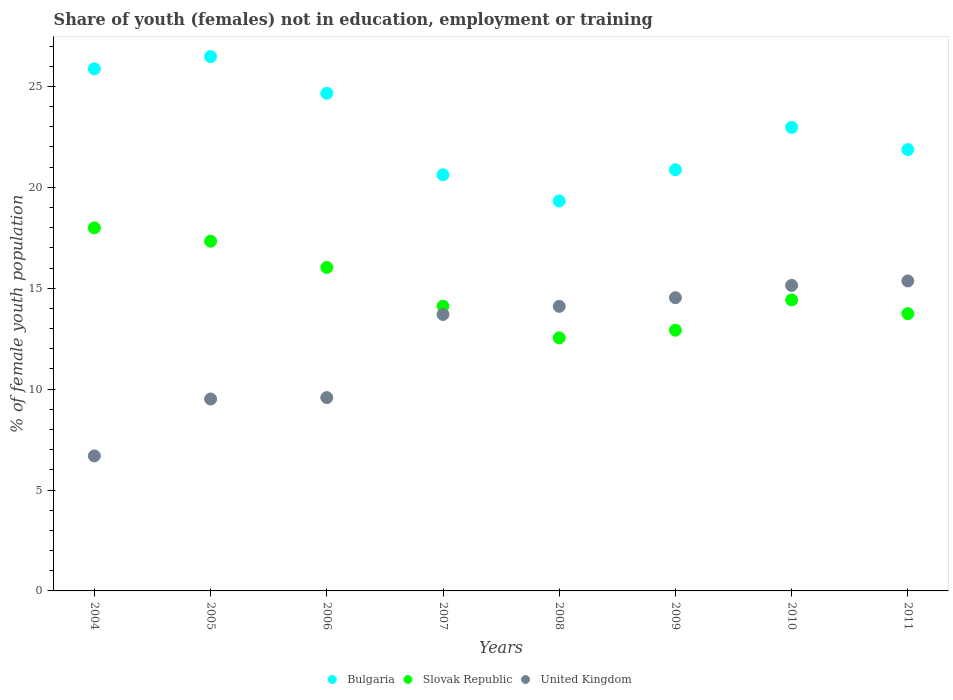How many different coloured dotlines are there?
Provide a short and direct response. 3. Is the number of dotlines equal to the number of legend labels?
Your answer should be compact. Yes. What is the percentage of unemployed female population in in Bulgaria in 2005?
Your answer should be compact. 26.48. Across all years, what is the maximum percentage of unemployed female population in in United Kingdom?
Provide a succinct answer. 15.36. Across all years, what is the minimum percentage of unemployed female population in in Bulgaria?
Your answer should be very brief. 19.32. In which year was the percentage of unemployed female population in in Slovak Republic maximum?
Your response must be concise. 2004. In which year was the percentage of unemployed female population in in Slovak Republic minimum?
Make the answer very short. 2008. What is the total percentage of unemployed female population in in United Kingdom in the graph?
Your answer should be compact. 98.61. What is the difference between the percentage of unemployed female population in in Bulgaria in 2004 and that in 2007?
Your response must be concise. 5.25. What is the difference between the percentage of unemployed female population in in Slovak Republic in 2006 and the percentage of unemployed female population in in United Kingdom in 2011?
Provide a succinct answer. 0.67. What is the average percentage of unemployed female population in in United Kingdom per year?
Provide a short and direct response. 12.33. In the year 2006, what is the difference between the percentage of unemployed female population in in Slovak Republic and percentage of unemployed female population in in Bulgaria?
Ensure brevity in your answer.  -8.63. What is the ratio of the percentage of unemployed female population in in Slovak Republic in 2004 to that in 2005?
Your answer should be compact. 1.04. Is the percentage of unemployed female population in in Slovak Republic in 2004 less than that in 2005?
Your answer should be very brief. No. Is the difference between the percentage of unemployed female population in in Slovak Republic in 2006 and 2007 greater than the difference between the percentage of unemployed female population in in Bulgaria in 2006 and 2007?
Make the answer very short. No. What is the difference between the highest and the second highest percentage of unemployed female population in in Slovak Republic?
Your answer should be very brief. 0.66. What is the difference between the highest and the lowest percentage of unemployed female population in in United Kingdom?
Give a very brief answer. 8.67. Is the sum of the percentage of unemployed female population in in Slovak Republic in 2007 and 2011 greater than the maximum percentage of unemployed female population in in Bulgaria across all years?
Your answer should be very brief. Yes. Does the graph contain any zero values?
Offer a very short reply. No. Does the graph contain grids?
Your answer should be compact. No. What is the title of the graph?
Keep it short and to the point. Share of youth (females) not in education, employment or training. What is the label or title of the Y-axis?
Keep it short and to the point. % of female youth population. What is the % of female youth population of Bulgaria in 2004?
Provide a short and direct response. 25.87. What is the % of female youth population in Slovak Republic in 2004?
Keep it short and to the point. 17.99. What is the % of female youth population of United Kingdom in 2004?
Provide a short and direct response. 6.69. What is the % of female youth population in Bulgaria in 2005?
Your answer should be compact. 26.48. What is the % of female youth population of Slovak Republic in 2005?
Offer a very short reply. 17.33. What is the % of female youth population in United Kingdom in 2005?
Provide a short and direct response. 9.51. What is the % of female youth population in Bulgaria in 2006?
Offer a terse response. 24.66. What is the % of female youth population of Slovak Republic in 2006?
Your answer should be very brief. 16.03. What is the % of female youth population of United Kingdom in 2006?
Keep it short and to the point. 9.58. What is the % of female youth population in Bulgaria in 2007?
Make the answer very short. 20.62. What is the % of female youth population in Slovak Republic in 2007?
Provide a succinct answer. 14.11. What is the % of female youth population in United Kingdom in 2007?
Ensure brevity in your answer.  13.7. What is the % of female youth population in Bulgaria in 2008?
Make the answer very short. 19.32. What is the % of female youth population of Slovak Republic in 2008?
Offer a very short reply. 12.54. What is the % of female youth population in United Kingdom in 2008?
Make the answer very short. 14.1. What is the % of female youth population in Bulgaria in 2009?
Keep it short and to the point. 20.87. What is the % of female youth population of Slovak Republic in 2009?
Keep it short and to the point. 12.92. What is the % of female youth population in United Kingdom in 2009?
Offer a very short reply. 14.53. What is the % of female youth population in Bulgaria in 2010?
Offer a terse response. 22.97. What is the % of female youth population in Slovak Republic in 2010?
Give a very brief answer. 14.42. What is the % of female youth population in United Kingdom in 2010?
Your answer should be very brief. 15.14. What is the % of female youth population of Bulgaria in 2011?
Keep it short and to the point. 21.87. What is the % of female youth population in Slovak Republic in 2011?
Give a very brief answer. 13.74. What is the % of female youth population in United Kingdom in 2011?
Make the answer very short. 15.36. Across all years, what is the maximum % of female youth population of Bulgaria?
Your response must be concise. 26.48. Across all years, what is the maximum % of female youth population in Slovak Republic?
Offer a very short reply. 17.99. Across all years, what is the maximum % of female youth population in United Kingdom?
Keep it short and to the point. 15.36. Across all years, what is the minimum % of female youth population of Bulgaria?
Make the answer very short. 19.32. Across all years, what is the minimum % of female youth population of Slovak Republic?
Keep it short and to the point. 12.54. Across all years, what is the minimum % of female youth population of United Kingdom?
Your response must be concise. 6.69. What is the total % of female youth population in Bulgaria in the graph?
Offer a terse response. 182.66. What is the total % of female youth population in Slovak Republic in the graph?
Your answer should be very brief. 119.08. What is the total % of female youth population in United Kingdom in the graph?
Your answer should be very brief. 98.61. What is the difference between the % of female youth population in Bulgaria in 2004 and that in 2005?
Your answer should be very brief. -0.61. What is the difference between the % of female youth population in Slovak Republic in 2004 and that in 2005?
Keep it short and to the point. 0.66. What is the difference between the % of female youth population of United Kingdom in 2004 and that in 2005?
Offer a terse response. -2.82. What is the difference between the % of female youth population in Bulgaria in 2004 and that in 2006?
Make the answer very short. 1.21. What is the difference between the % of female youth population in Slovak Republic in 2004 and that in 2006?
Keep it short and to the point. 1.96. What is the difference between the % of female youth population of United Kingdom in 2004 and that in 2006?
Your response must be concise. -2.89. What is the difference between the % of female youth population of Bulgaria in 2004 and that in 2007?
Provide a short and direct response. 5.25. What is the difference between the % of female youth population of Slovak Republic in 2004 and that in 2007?
Ensure brevity in your answer.  3.88. What is the difference between the % of female youth population in United Kingdom in 2004 and that in 2007?
Offer a terse response. -7.01. What is the difference between the % of female youth population of Bulgaria in 2004 and that in 2008?
Your response must be concise. 6.55. What is the difference between the % of female youth population of Slovak Republic in 2004 and that in 2008?
Your answer should be compact. 5.45. What is the difference between the % of female youth population in United Kingdom in 2004 and that in 2008?
Your answer should be compact. -7.41. What is the difference between the % of female youth population in Slovak Republic in 2004 and that in 2009?
Your answer should be compact. 5.07. What is the difference between the % of female youth population of United Kingdom in 2004 and that in 2009?
Your answer should be compact. -7.84. What is the difference between the % of female youth population in Slovak Republic in 2004 and that in 2010?
Keep it short and to the point. 3.57. What is the difference between the % of female youth population of United Kingdom in 2004 and that in 2010?
Provide a succinct answer. -8.45. What is the difference between the % of female youth population in Slovak Republic in 2004 and that in 2011?
Give a very brief answer. 4.25. What is the difference between the % of female youth population in United Kingdom in 2004 and that in 2011?
Ensure brevity in your answer.  -8.67. What is the difference between the % of female youth population of Bulgaria in 2005 and that in 2006?
Keep it short and to the point. 1.82. What is the difference between the % of female youth population of United Kingdom in 2005 and that in 2006?
Your answer should be compact. -0.07. What is the difference between the % of female youth population in Bulgaria in 2005 and that in 2007?
Make the answer very short. 5.86. What is the difference between the % of female youth population in Slovak Republic in 2005 and that in 2007?
Your answer should be very brief. 3.22. What is the difference between the % of female youth population of United Kingdom in 2005 and that in 2007?
Your answer should be very brief. -4.19. What is the difference between the % of female youth population in Bulgaria in 2005 and that in 2008?
Keep it short and to the point. 7.16. What is the difference between the % of female youth population of Slovak Republic in 2005 and that in 2008?
Offer a terse response. 4.79. What is the difference between the % of female youth population in United Kingdom in 2005 and that in 2008?
Keep it short and to the point. -4.59. What is the difference between the % of female youth population of Bulgaria in 2005 and that in 2009?
Your answer should be compact. 5.61. What is the difference between the % of female youth population of Slovak Republic in 2005 and that in 2009?
Your answer should be compact. 4.41. What is the difference between the % of female youth population of United Kingdom in 2005 and that in 2009?
Ensure brevity in your answer.  -5.02. What is the difference between the % of female youth population of Bulgaria in 2005 and that in 2010?
Provide a short and direct response. 3.51. What is the difference between the % of female youth population in Slovak Republic in 2005 and that in 2010?
Provide a succinct answer. 2.91. What is the difference between the % of female youth population in United Kingdom in 2005 and that in 2010?
Offer a terse response. -5.63. What is the difference between the % of female youth population of Bulgaria in 2005 and that in 2011?
Your answer should be compact. 4.61. What is the difference between the % of female youth population in Slovak Republic in 2005 and that in 2011?
Make the answer very short. 3.59. What is the difference between the % of female youth population in United Kingdom in 2005 and that in 2011?
Ensure brevity in your answer.  -5.85. What is the difference between the % of female youth population of Bulgaria in 2006 and that in 2007?
Offer a very short reply. 4.04. What is the difference between the % of female youth population in Slovak Republic in 2006 and that in 2007?
Offer a very short reply. 1.92. What is the difference between the % of female youth population in United Kingdom in 2006 and that in 2007?
Your answer should be very brief. -4.12. What is the difference between the % of female youth population in Bulgaria in 2006 and that in 2008?
Offer a very short reply. 5.34. What is the difference between the % of female youth population of Slovak Republic in 2006 and that in 2008?
Keep it short and to the point. 3.49. What is the difference between the % of female youth population of United Kingdom in 2006 and that in 2008?
Make the answer very short. -4.52. What is the difference between the % of female youth population in Bulgaria in 2006 and that in 2009?
Your response must be concise. 3.79. What is the difference between the % of female youth population of Slovak Republic in 2006 and that in 2009?
Your answer should be very brief. 3.11. What is the difference between the % of female youth population in United Kingdom in 2006 and that in 2009?
Offer a very short reply. -4.95. What is the difference between the % of female youth population in Bulgaria in 2006 and that in 2010?
Make the answer very short. 1.69. What is the difference between the % of female youth population in Slovak Republic in 2006 and that in 2010?
Your answer should be compact. 1.61. What is the difference between the % of female youth population in United Kingdom in 2006 and that in 2010?
Ensure brevity in your answer.  -5.56. What is the difference between the % of female youth population in Bulgaria in 2006 and that in 2011?
Offer a terse response. 2.79. What is the difference between the % of female youth population of Slovak Republic in 2006 and that in 2011?
Your answer should be very brief. 2.29. What is the difference between the % of female youth population of United Kingdom in 2006 and that in 2011?
Ensure brevity in your answer.  -5.78. What is the difference between the % of female youth population of Bulgaria in 2007 and that in 2008?
Your response must be concise. 1.3. What is the difference between the % of female youth population in Slovak Republic in 2007 and that in 2008?
Offer a very short reply. 1.57. What is the difference between the % of female youth population in United Kingdom in 2007 and that in 2008?
Offer a terse response. -0.4. What is the difference between the % of female youth population of Slovak Republic in 2007 and that in 2009?
Make the answer very short. 1.19. What is the difference between the % of female youth population of United Kingdom in 2007 and that in 2009?
Your response must be concise. -0.83. What is the difference between the % of female youth population of Bulgaria in 2007 and that in 2010?
Your answer should be very brief. -2.35. What is the difference between the % of female youth population of Slovak Republic in 2007 and that in 2010?
Make the answer very short. -0.31. What is the difference between the % of female youth population of United Kingdom in 2007 and that in 2010?
Offer a very short reply. -1.44. What is the difference between the % of female youth population of Bulgaria in 2007 and that in 2011?
Your response must be concise. -1.25. What is the difference between the % of female youth population of Slovak Republic in 2007 and that in 2011?
Provide a short and direct response. 0.37. What is the difference between the % of female youth population in United Kingdom in 2007 and that in 2011?
Provide a short and direct response. -1.66. What is the difference between the % of female youth population of Bulgaria in 2008 and that in 2009?
Provide a succinct answer. -1.55. What is the difference between the % of female youth population in Slovak Republic in 2008 and that in 2009?
Your answer should be compact. -0.38. What is the difference between the % of female youth population of United Kingdom in 2008 and that in 2009?
Offer a very short reply. -0.43. What is the difference between the % of female youth population in Bulgaria in 2008 and that in 2010?
Keep it short and to the point. -3.65. What is the difference between the % of female youth population of Slovak Republic in 2008 and that in 2010?
Provide a succinct answer. -1.88. What is the difference between the % of female youth population in United Kingdom in 2008 and that in 2010?
Ensure brevity in your answer.  -1.04. What is the difference between the % of female youth population in Bulgaria in 2008 and that in 2011?
Your answer should be very brief. -2.55. What is the difference between the % of female youth population in Slovak Republic in 2008 and that in 2011?
Give a very brief answer. -1.2. What is the difference between the % of female youth population of United Kingdom in 2008 and that in 2011?
Give a very brief answer. -1.26. What is the difference between the % of female youth population in Bulgaria in 2009 and that in 2010?
Provide a short and direct response. -2.1. What is the difference between the % of female youth population in Slovak Republic in 2009 and that in 2010?
Your answer should be very brief. -1.5. What is the difference between the % of female youth population in United Kingdom in 2009 and that in 2010?
Your answer should be very brief. -0.61. What is the difference between the % of female youth population of Slovak Republic in 2009 and that in 2011?
Your answer should be very brief. -0.82. What is the difference between the % of female youth population of United Kingdom in 2009 and that in 2011?
Provide a succinct answer. -0.83. What is the difference between the % of female youth population in Slovak Republic in 2010 and that in 2011?
Offer a terse response. 0.68. What is the difference between the % of female youth population in United Kingdom in 2010 and that in 2011?
Offer a terse response. -0.22. What is the difference between the % of female youth population of Bulgaria in 2004 and the % of female youth population of Slovak Republic in 2005?
Give a very brief answer. 8.54. What is the difference between the % of female youth population in Bulgaria in 2004 and the % of female youth population in United Kingdom in 2005?
Offer a terse response. 16.36. What is the difference between the % of female youth population of Slovak Republic in 2004 and the % of female youth population of United Kingdom in 2005?
Your answer should be compact. 8.48. What is the difference between the % of female youth population of Bulgaria in 2004 and the % of female youth population of Slovak Republic in 2006?
Your response must be concise. 9.84. What is the difference between the % of female youth population of Bulgaria in 2004 and the % of female youth population of United Kingdom in 2006?
Provide a short and direct response. 16.29. What is the difference between the % of female youth population in Slovak Republic in 2004 and the % of female youth population in United Kingdom in 2006?
Offer a very short reply. 8.41. What is the difference between the % of female youth population in Bulgaria in 2004 and the % of female youth population in Slovak Republic in 2007?
Provide a short and direct response. 11.76. What is the difference between the % of female youth population of Bulgaria in 2004 and the % of female youth population of United Kingdom in 2007?
Keep it short and to the point. 12.17. What is the difference between the % of female youth population in Slovak Republic in 2004 and the % of female youth population in United Kingdom in 2007?
Offer a very short reply. 4.29. What is the difference between the % of female youth population in Bulgaria in 2004 and the % of female youth population in Slovak Republic in 2008?
Your answer should be very brief. 13.33. What is the difference between the % of female youth population in Bulgaria in 2004 and the % of female youth population in United Kingdom in 2008?
Keep it short and to the point. 11.77. What is the difference between the % of female youth population of Slovak Republic in 2004 and the % of female youth population of United Kingdom in 2008?
Offer a terse response. 3.89. What is the difference between the % of female youth population of Bulgaria in 2004 and the % of female youth population of Slovak Republic in 2009?
Your answer should be compact. 12.95. What is the difference between the % of female youth population in Bulgaria in 2004 and the % of female youth population in United Kingdom in 2009?
Ensure brevity in your answer.  11.34. What is the difference between the % of female youth population of Slovak Republic in 2004 and the % of female youth population of United Kingdom in 2009?
Provide a succinct answer. 3.46. What is the difference between the % of female youth population of Bulgaria in 2004 and the % of female youth population of Slovak Republic in 2010?
Offer a terse response. 11.45. What is the difference between the % of female youth population of Bulgaria in 2004 and the % of female youth population of United Kingdom in 2010?
Offer a terse response. 10.73. What is the difference between the % of female youth population of Slovak Republic in 2004 and the % of female youth population of United Kingdom in 2010?
Offer a terse response. 2.85. What is the difference between the % of female youth population of Bulgaria in 2004 and the % of female youth population of Slovak Republic in 2011?
Ensure brevity in your answer.  12.13. What is the difference between the % of female youth population in Bulgaria in 2004 and the % of female youth population in United Kingdom in 2011?
Offer a very short reply. 10.51. What is the difference between the % of female youth population in Slovak Republic in 2004 and the % of female youth population in United Kingdom in 2011?
Offer a very short reply. 2.63. What is the difference between the % of female youth population of Bulgaria in 2005 and the % of female youth population of Slovak Republic in 2006?
Your answer should be very brief. 10.45. What is the difference between the % of female youth population of Bulgaria in 2005 and the % of female youth population of United Kingdom in 2006?
Your answer should be very brief. 16.9. What is the difference between the % of female youth population in Slovak Republic in 2005 and the % of female youth population in United Kingdom in 2006?
Offer a terse response. 7.75. What is the difference between the % of female youth population of Bulgaria in 2005 and the % of female youth population of Slovak Republic in 2007?
Make the answer very short. 12.37. What is the difference between the % of female youth population of Bulgaria in 2005 and the % of female youth population of United Kingdom in 2007?
Offer a terse response. 12.78. What is the difference between the % of female youth population of Slovak Republic in 2005 and the % of female youth population of United Kingdom in 2007?
Offer a very short reply. 3.63. What is the difference between the % of female youth population of Bulgaria in 2005 and the % of female youth population of Slovak Republic in 2008?
Keep it short and to the point. 13.94. What is the difference between the % of female youth population in Bulgaria in 2005 and the % of female youth population in United Kingdom in 2008?
Give a very brief answer. 12.38. What is the difference between the % of female youth population of Slovak Republic in 2005 and the % of female youth population of United Kingdom in 2008?
Provide a succinct answer. 3.23. What is the difference between the % of female youth population of Bulgaria in 2005 and the % of female youth population of Slovak Republic in 2009?
Offer a terse response. 13.56. What is the difference between the % of female youth population of Bulgaria in 2005 and the % of female youth population of United Kingdom in 2009?
Your answer should be very brief. 11.95. What is the difference between the % of female youth population of Slovak Republic in 2005 and the % of female youth population of United Kingdom in 2009?
Ensure brevity in your answer.  2.8. What is the difference between the % of female youth population in Bulgaria in 2005 and the % of female youth population in Slovak Republic in 2010?
Your answer should be very brief. 12.06. What is the difference between the % of female youth population in Bulgaria in 2005 and the % of female youth population in United Kingdom in 2010?
Your response must be concise. 11.34. What is the difference between the % of female youth population in Slovak Republic in 2005 and the % of female youth population in United Kingdom in 2010?
Offer a terse response. 2.19. What is the difference between the % of female youth population in Bulgaria in 2005 and the % of female youth population in Slovak Republic in 2011?
Offer a terse response. 12.74. What is the difference between the % of female youth population in Bulgaria in 2005 and the % of female youth population in United Kingdom in 2011?
Provide a succinct answer. 11.12. What is the difference between the % of female youth population in Slovak Republic in 2005 and the % of female youth population in United Kingdom in 2011?
Your response must be concise. 1.97. What is the difference between the % of female youth population in Bulgaria in 2006 and the % of female youth population in Slovak Republic in 2007?
Your answer should be compact. 10.55. What is the difference between the % of female youth population in Bulgaria in 2006 and the % of female youth population in United Kingdom in 2007?
Your answer should be compact. 10.96. What is the difference between the % of female youth population in Slovak Republic in 2006 and the % of female youth population in United Kingdom in 2007?
Your answer should be compact. 2.33. What is the difference between the % of female youth population of Bulgaria in 2006 and the % of female youth population of Slovak Republic in 2008?
Ensure brevity in your answer.  12.12. What is the difference between the % of female youth population in Bulgaria in 2006 and the % of female youth population in United Kingdom in 2008?
Your response must be concise. 10.56. What is the difference between the % of female youth population in Slovak Republic in 2006 and the % of female youth population in United Kingdom in 2008?
Offer a terse response. 1.93. What is the difference between the % of female youth population in Bulgaria in 2006 and the % of female youth population in Slovak Republic in 2009?
Offer a very short reply. 11.74. What is the difference between the % of female youth population in Bulgaria in 2006 and the % of female youth population in United Kingdom in 2009?
Make the answer very short. 10.13. What is the difference between the % of female youth population of Slovak Republic in 2006 and the % of female youth population of United Kingdom in 2009?
Your response must be concise. 1.5. What is the difference between the % of female youth population in Bulgaria in 2006 and the % of female youth population in Slovak Republic in 2010?
Provide a succinct answer. 10.24. What is the difference between the % of female youth population in Bulgaria in 2006 and the % of female youth population in United Kingdom in 2010?
Your answer should be compact. 9.52. What is the difference between the % of female youth population in Slovak Republic in 2006 and the % of female youth population in United Kingdom in 2010?
Ensure brevity in your answer.  0.89. What is the difference between the % of female youth population of Bulgaria in 2006 and the % of female youth population of Slovak Republic in 2011?
Keep it short and to the point. 10.92. What is the difference between the % of female youth population of Bulgaria in 2006 and the % of female youth population of United Kingdom in 2011?
Your answer should be compact. 9.3. What is the difference between the % of female youth population in Slovak Republic in 2006 and the % of female youth population in United Kingdom in 2011?
Offer a very short reply. 0.67. What is the difference between the % of female youth population in Bulgaria in 2007 and the % of female youth population in Slovak Republic in 2008?
Make the answer very short. 8.08. What is the difference between the % of female youth population in Bulgaria in 2007 and the % of female youth population in United Kingdom in 2008?
Give a very brief answer. 6.52. What is the difference between the % of female youth population in Slovak Republic in 2007 and the % of female youth population in United Kingdom in 2008?
Your answer should be compact. 0.01. What is the difference between the % of female youth population in Bulgaria in 2007 and the % of female youth population in United Kingdom in 2009?
Offer a very short reply. 6.09. What is the difference between the % of female youth population of Slovak Republic in 2007 and the % of female youth population of United Kingdom in 2009?
Provide a short and direct response. -0.42. What is the difference between the % of female youth population of Bulgaria in 2007 and the % of female youth population of United Kingdom in 2010?
Keep it short and to the point. 5.48. What is the difference between the % of female youth population in Slovak Republic in 2007 and the % of female youth population in United Kingdom in 2010?
Your answer should be compact. -1.03. What is the difference between the % of female youth population in Bulgaria in 2007 and the % of female youth population in Slovak Republic in 2011?
Offer a terse response. 6.88. What is the difference between the % of female youth population of Bulgaria in 2007 and the % of female youth population of United Kingdom in 2011?
Keep it short and to the point. 5.26. What is the difference between the % of female youth population in Slovak Republic in 2007 and the % of female youth population in United Kingdom in 2011?
Ensure brevity in your answer.  -1.25. What is the difference between the % of female youth population of Bulgaria in 2008 and the % of female youth population of Slovak Republic in 2009?
Give a very brief answer. 6.4. What is the difference between the % of female youth population in Bulgaria in 2008 and the % of female youth population in United Kingdom in 2009?
Your answer should be compact. 4.79. What is the difference between the % of female youth population of Slovak Republic in 2008 and the % of female youth population of United Kingdom in 2009?
Keep it short and to the point. -1.99. What is the difference between the % of female youth population of Bulgaria in 2008 and the % of female youth population of Slovak Republic in 2010?
Your answer should be very brief. 4.9. What is the difference between the % of female youth population in Bulgaria in 2008 and the % of female youth population in United Kingdom in 2010?
Offer a terse response. 4.18. What is the difference between the % of female youth population in Slovak Republic in 2008 and the % of female youth population in United Kingdom in 2010?
Your response must be concise. -2.6. What is the difference between the % of female youth population of Bulgaria in 2008 and the % of female youth population of Slovak Republic in 2011?
Keep it short and to the point. 5.58. What is the difference between the % of female youth population in Bulgaria in 2008 and the % of female youth population in United Kingdom in 2011?
Give a very brief answer. 3.96. What is the difference between the % of female youth population in Slovak Republic in 2008 and the % of female youth population in United Kingdom in 2011?
Make the answer very short. -2.82. What is the difference between the % of female youth population of Bulgaria in 2009 and the % of female youth population of Slovak Republic in 2010?
Provide a short and direct response. 6.45. What is the difference between the % of female youth population in Bulgaria in 2009 and the % of female youth population in United Kingdom in 2010?
Keep it short and to the point. 5.73. What is the difference between the % of female youth population in Slovak Republic in 2009 and the % of female youth population in United Kingdom in 2010?
Provide a succinct answer. -2.22. What is the difference between the % of female youth population in Bulgaria in 2009 and the % of female youth population in Slovak Republic in 2011?
Offer a very short reply. 7.13. What is the difference between the % of female youth population in Bulgaria in 2009 and the % of female youth population in United Kingdom in 2011?
Give a very brief answer. 5.51. What is the difference between the % of female youth population of Slovak Republic in 2009 and the % of female youth population of United Kingdom in 2011?
Give a very brief answer. -2.44. What is the difference between the % of female youth population of Bulgaria in 2010 and the % of female youth population of Slovak Republic in 2011?
Make the answer very short. 9.23. What is the difference between the % of female youth population in Bulgaria in 2010 and the % of female youth population in United Kingdom in 2011?
Keep it short and to the point. 7.61. What is the difference between the % of female youth population in Slovak Republic in 2010 and the % of female youth population in United Kingdom in 2011?
Your answer should be very brief. -0.94. What is the average % of female youth population of Bulgaria per year?
Your answer should be very brief. 22.83. What is the average % of female youth population in Slovak Republic per year?
Offer a very short reply. 14.88. What is the average % of female youth population in United Kingdom per year?
Your answer should be compact. 12.33. In the year 2004, what is the difference between the % of female youth population of Bulgaria and % of female youth population of Slovak Republic?
Provide a succinct answer. 7.88. In the year 2004, what is the difference between the % of female youth population in Bulgaria and % of female youth population in United Kingdom?
Your answer should be very brief. 19.18. In the year 2004, what is the difference between the % of female youth population of Slovak Republic and % of female youth population of United Kingdom?
Offer a terse response. 11.3. In the year 2005, what is the difference between the % of female youth population in Bulgaria and % of female youth population in Slovak Republic?
Your answer should be very brief. 9.15. In the year 2005, what is the difference between the % of female youth population of Bulgaria and % of female youth population of United Kingdom?
Your response must be concise. 16.97. In the year 2005, what is the difference between the % of female youth population of Slovak Republic and % of female youth population of United Kingdom?
Keep it short and to the point. 7.82. In the year 2006, what is the difference between the % of female youth population in Bulgaria and % of female youth population in Slovak Republic?
Your answer should be compact. 8.63. In the year 2006, what is the difference between the % of female youth population of Bulgaria and % of female youth population of United Kingdom?
Make the answer very short. 15.08. In the year 2006, what is the difference between the % of female youth population of Slovak Republic and % of female youth population of United Kingdom?
Provide a succinct answer. 6.45. In the year 2007, what is the difference between the % of female youth population of Bulgaria and % of female youth population of Slovak Republic?
Keep it short and to the point. 6.51. In the year 2007, what is the difference between the % of female youth population of Bulgaria and % of female youth population of United Kingdom?
Ensure brevity in your answer.  6.92. In the year 2007, what is the difference between the % of female youth population in Slovak Republic and % of female youth population in United Kingdom?
Offer a terse response. 0.41. In the year 2008, what is the difference between the % of female youth population of Bulgaria and % of female youth population of Slovak Republic?
Offer a terse response. 6.78. In the year 2008, what is the difference between the % of female youth population of Bulgaria and % of female youth population of United Kingdom?
Your response must be concise. 5.22. In the year 2008, what is the difference between the % of female youth population of Slovak Republic and % of female youth population of United Kingdom?
Your response must be concise. -1.56. In the year 2009, what is the difference between the % of female youth population of Bulgaria and % of female youth population of Slovak Republic?
Provide a succinct answer. 7.95. In the year 2009, what is the difference between the % of female youth population of Bulgaria and % of female youth population of United Kingdom?
Your answer should be compact. 6.34. In the year 2009, what is the difference between the % of female youth population of Slovak Republic and % of female youth population of United Kingdom?
Your answer should be very brief. -1.61. In the year 2010, what is the difference between the % of female youth population in Bulgaria and % of female youth population in Slovak Republic?
Keep it short and to the point. 8.55. In the year 2010, what is the difference between the % of female youth population in Bulgaria and % of female youth population in United Kingdom?
Offer a terse response. 7.83. In the year 2010, what is the difference between the % of female youth population in Slovak Republic and % of female youth population in United Kingdom?
Your answer should be compact. -0.72. In the year 2011, what is the difference between the % of female youth population of Bulgaria and % of female youth population of Slovak Republic?
Your answer should be very brief. 8.13. In the year 2011, what is the difference between the % of female youth population of Bulgaria and % of female youth population of United Kingdom?
Provide a short and direct response. 6.51. In the year 2011, what is the difference between the % of female youth population of Slovak Republic and % of female youth population of United Kingdom?
Provide a short and direct response. -1.62. What is the ratio of the % of female youth population of Slovak Republic in 2004 to that in 2005?
Your answer should be very brief. 1.04. What is the ratio of the % of female youth population in United Kingdom in 2004 to that in 2005?
Your response must be concise. 0.7. What is the ratio of the % of female youth population in Bulgaria in 2004 to that in 2006?
Make the answer very short. 1.05. What is the ratio of the % of female youth population in Slovak Republic in 2004 to that in 2006?
Your response must be concise. 1.12. What is the ratio of the % of female youth population in United Kingdom in 2004 to that in 2006?
Your answer should be very brief. 0.7. What is the ratio of the % of female youth population of Bulgaria in 2004 to that in 2007?
Make the answer very short. 1.25. What is the ratio of the % of female youth population of Slovak Republic in 2004 to that in 2007?
Ensure brevity in your answer.  1.27. What is the ratio of the % of female youth population in United Kingdom in 2004 to that in 2007?
Provide a succinct answer. 0.49. What is the ratio of the % of female youth population of Bulgaria in 2004 to that in 2008?
Provide a succinct answer. 1.34. What is the ratio of the % of female youth population of Slovak Republic in 2004 to that in 2008?
Provide a short and direct response. 1.43. What is the ratio of the % of female youth population in United Kingdom in 2004 to that in 2008?
Keep it short and to the point. 0.47. What is the ratio of the % of female youth population of Bulgaria in 2004 to that in 2009?
Keep it short and to the point. 1.24. What is the ratio of the % of female youth population of Slovak Republic in 2004 to that in 2009?
Keep it short and to the point. 1.39. What is the ratio of the % of female youth population of United Kingdom in 2004 to that in 2009?
Keep it short and to the point. 0.46. What is the ratio of the % of female youth population in Bulgaria in 2004 to that in 2010?
Ensure brevity in your answer.  1.13. What is the ratio of the % of female youth population in Slovak Republic in 2004 to that in 2010?
Offer a very short reply. 1.25. What is the ratio of the % of female youth population in United Kingdom in 2004 to that in 2010?
Give a very brief answer. 0.44. What is the ratio of the % of female youth population of Bulgaria in 2004 to that in 2011?
Ensure brevity in your answer.  1.18. What is the ratio of the % of female youth population in Slovak Republic in 2004 to that in 2011?
Provide a short and direct response. 1.31. What is the ratio of the % of female youth population in United Kingdom in 2004 to that in 2011?
Your answer should be compact. 0.44. What is the ratio of the % of female youth population in Bulgaria in 2005 to that in 2006?
Your answer should be compact. 1.07. What is the ratio of the % of female youth population of Slovak Republic in 2005 to that in 2006?
Offer a very short reply. 1.08. What is the ratio of the % of female youth population in United Kingdom in 2005 to that in 2006?
Keep it short and to the point. 0.99. What is the ratio of the % of female youth population in Bulgaria in 2005 to that in 2007?
Provide a short and direct response. 1.28. What is the ratio of the % of female youth population of Slovak Republic in 2005 to that in 2007?
Your answer should be compact. 1.23. What is the ratio of the % of female youth population of United Kingdom in 2005 to that in 2007?
Keep it short and to the point. 0.69. What is the ratio of the % of female youth population in Bulgaria in 2005 to that in 2008?
Your response must be concise. 1.37. What is the ratio of the % of female youth population of Slovak Republic in 2005 to that in 2008?
Provide a short and direct response. 1.38. What is the ratio of the % of female youth population of United Kingdom in 2005 to that in 2008?
Provide a succinct answer. 0.67. What is the ratio of the % of female youth population in Bulgaria in 2005 to that in 2009?
Provide a succinct answer. 1.27. What is the ratio of the % of female youth population in Slovak Republic in 2005 to that in 2009?
Provide a short and direct response. 1.34. What is the ratio of the % of female youth population in United Kingdom in 2005 to that in 2009?
Your answer should be very brief. 0.65. What is the ratio of the % of female youth population in Bulgaria in 2005 to that in 2010?
Your response must be concise. 1.15. What is the ratio of the % of female youth population in Slovak Republic in 2005 to that in 2010?
Keep it short and to the point. 1.2. What is the ratio of the % of female youth population in United Kingdom in 2005 to that in 2010?
Give a very brief answer. 0.63. What is the ratio of the % of female youth population in Bulgaria in 2005 to that in 2011?
Offer a very short reply. 1.21. What is the ratio of the % of female youth population in Slovak Republic in 2005 to that in 2011?
Your response must be concise. 1.26. What is the ratio of the % of female youth population of United Kingdom in 2005 to that in 2011?
Provide a short and direct response. 0.62. What is the ratio of the % of female youth population of Bulgaria in 2006 to that in 2007?
Your response must be concise. 1.2. What is the ratio of the % of female youth population in Slovak Republic in 2006 to that in 2007?
Provide a short and direct response. 1.14. What is the ratio of the % of female youth population in United Kingdom in 2006 to that in 2007?
Offer a very short reply. 0.7. What is the ratio of the % of female youth population in Bulgaria in 2006 to that in 2008?
Your answer should be compact. 1.28. What is the ratio of the % of female youth population in Slovak Republic in 2006 to that in 2008?
Ensure brevity in your answer.  1.28. What is the ratio of the % of female youth population of United Kingdom in 2006 to that in 2008?
Your answer should be compact. 0.68. What is the ratio of the % of female youth population in Bulgaria in 2006 to that in 2009?
Provide a short and direct response. 1.18. What is the ratio of the % of female youth population of Slovak Republic in 2006 to that in 2009?
Provide a succinct answer. 1.24. What is the ratio of the % of female youth population of United Kingdom in 2006 to that in 2009?
Your answer should be very brief. 0.66. What is the ratio of the % of female youth population of Bulgaria in 2006 to that in 2010?
Your answer should be very brief. 1.07. What is the ratio of the % of female youth population of Slovak Republic in 2006 to that in 2010?
Your answer should be very brief. 1.11. What is the ratio of the % of female youth population of United Kingdom in 2006 to that in 2010?
Offer a very short reply. 0.63. What is the ratio of the % of female youth population of Bulgaria in 2006 to that in 2011?
Your answer should be very brief. 1.13. What is the ratio of the % of female youth population in Slovak Republic in 2006 to that in 2011?
Provide a succinct answer. 1.17. What is the ratio of the % of female youth population in United Kingdom in 2006 to that in 2011?
Ensure brevity in your answer.  0.62. What is the ratio of the % of female youth population in Bulgaria in 2007 to that in 2008?
Offer a very short reply. 1.07. What is the ratio of the % of female youth population of Slovak Republic in 2007 to that in 2008?
Offer a very short reply. 1.13. What is the ratio of the % of female youth population in United Kingdom in 2007 to that in 2008?
Make the answer very short. 0.97. What is the ratio of the % of female youth population of Bulgaria in 2007 to that in 2009?
Your answer should be compact. 0.99. What is the ratio of the % of female youth population in Slovak Republic in 2007 to that in 2009?
Provide a short and direct response. 1.09. What is the ratio of the % of female youth population of United Kingdom in 2007 to that in 2009?
Your answer should be compact. 0.94. What is the ratio of the % of female youth population of Bulgaria in 2007 to that in 2010?
Your answer should be very brief. 0.9. What is the ratio of the % of female youth population in Slovak Republic in 2007 to that in 2010?
Provide a succinct answer. 0.98. What is the ratio of the % of female youth population of United Kingdom in 2007 to that in 2010?
Provide a succinct answer. 0.9. What is the ratio of the % of female youth population of Bulgaria in 2007 to that in 2011?
Provide a short and direct response. 0.94. What is the ratio of the % of female youth population in Slovak Republic in 2007 to that in 2011?
Your response must be concise. 1.03. What is the ratio of the % of female youth population in United Kingdom in 2007 to that in 2011?
Offer a very short reply. 0.89. What is the ratio of the % of female youth population in Bulgaria in 2008 to that in 2009?
Offer a terse response. 0.93. What is the ratio of the % of female youth population of Slovak Republic in 2008 to that in 2009?
Your response must be concise. 0.97. What is the ratio of the % of female youth population of United Kingdom in 2008 to that in 2009?
Make the answer very short. 0.97. What is the ratio of the % of female youth population in Bulgaria in 2008 to that in 2010?
Keep it short and to the point. 0.84. What is the ratio of the % of female youth population in Slovak Republic in 2008 to that in 2010?
Offer a very short reply. 0.87. What is the ratio of the % of female youth population of United Kingdom in 2008 to that in 2010?
Offer a very short reply. 0.93. What is the ratio of the % of female youth population of Bulgaria in 2008 to that in 2011?
Make the answer very short. 0.88. What is the ratio of the % of female youth population in Slovak Republic in 2008 to that in 2011?
Provide a short and direct response. 0.91. What is the ratio of the % of female youth population of United Kingdom in 2008 to that in 2011?
Keep it short and to the point. 0.92. What is the ratio of the % of female youth population in Bulgaria in 2009 to that in 2010?
Ensure brevity in your answer.  0.91. What is the ratio of the % of female youth population in Slovak Republic in 2009 to that in 2010?
Offer a very short reply. 0.9. What is the ratio of the % of female youth population in United Kingdom in 2009 to that in 2010?
Offer a very short reply. 0.96. What is the ratio of the % of female youth population in Bulgaria in 2009 to that in 2011?
Provide a short and direct response. 0.95. What is the ratio of the % of female youth population of Slovak Republic in 2009 to that in 2011?
Give a very brief answer. 0.94. What is the ratio of the % of female youth population in United Kingdom in 2009 to that in 2011?
Provide a succinct answer. 0.95. What is the ratio of the % of female youth population in Bulgaria in 2010 to that in 2011?
Your answer should be compact. 1.05. What is the ratio of the % of female youth population of Slovak Republic in 2010 to that in 2011?
Ensure brevity in your answer.  1.05. What is the ratio of the % of female youth population of United Kingdom in 2010 to that in 2011?
Give a very brief answer. 0.99. What is the difference between the highest and the second highest % of female youth population in Bulgaria?
Give a very brief answer. 0.61. What is the difference between the highest and the second highest % of female youth population of Slovak Republic?
Make the answer very short. 0.66. What is the difference between the highest and the second highest % of female youth population of United Kingdom?
Your response must be concise. 0.22. What is the difference between the highest and the lowest % of female youth population of Bulgaria?
Ensure brevity in your answer.  7.16. What is the difference between the highest and the lowest % of female youth population in Slovak Republic?
Your response must be concise. 5.45. What is the difference between the highest and the lowest % of female youth population of United Kingdom?
Provide a short and direct response. 8.67. 